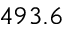Convert formula to latex. <formula><loc_0><loc_0><loc_500><loc_500>4 9 3 . 6</formula> 